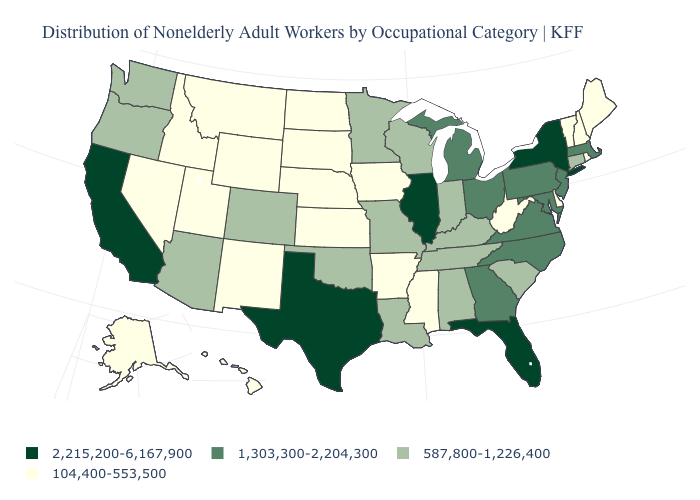What is the value of Delaware?
Write a very short answer. 104,400-553,500. Name the states that have a value in the range 104,400-553,500?
Concise answer only. Alaska, Arkansas, Delaware, Hawaii, Idaho, Iowa, Kansas, Maine, Mississippi, Montana, Nebraska, Nevada, New Hampshire, New Mexico, North Dakota, Rhode Island, South Dakota, Utah, Vermont, West Virginia, Wyoming. What is the lowest value in the MidWest?
Keep it brief. 104,400-553,500. What is the value of Montana?
Keep it brief. 104,400-553,500. What is the highest value in the USA?
Short answer required. 2,215,200-6,167,900. Does Pennsylvania have a higher value than Illinois?
Concise answer only. No. Which states have the lowest value in the USA?
Be succinct. Alaska, Arkansas, Delaware, Hawaii, Idaho, Iowa, Kansas, Maine, Mississippi, Montana, Nebraska, Nevada, New Hampshire, New Mexico, North Dakota, Rhode Island, South Dakota, Utah, Vermont, West Virginia, Wyoming. Does Florida have the highest value in the USA?
Be succinct. Yes. What is the highest value in states that border Indiana?
Write a very short answer. 2,215,200-6,167,900. What is the highest value in the Northeast ?
Keep it brief. 2,215,200-6,167,900. What is the highest value in states that border Arizona?
Answer briefly. 2,215,200-6,167,900. Which states hav the highest value in the MidWest?
Write a very short answer. Illinois. Name the states that have a value in the range 1,303,300-2,204,300?
Give a very brief answer. Georgia, Maryland, Massachusetts, Michigan, New Jersey, North Carolina, Ohio, Pennsylvania, Virginia. What is the lowest value in states that border Texas?
Keep it brief. 104,400-553,500. 